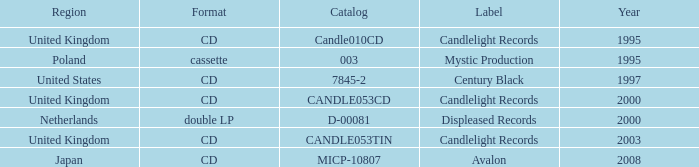What was the Candlelight Records Catalog of Candle053tin format? CD. 